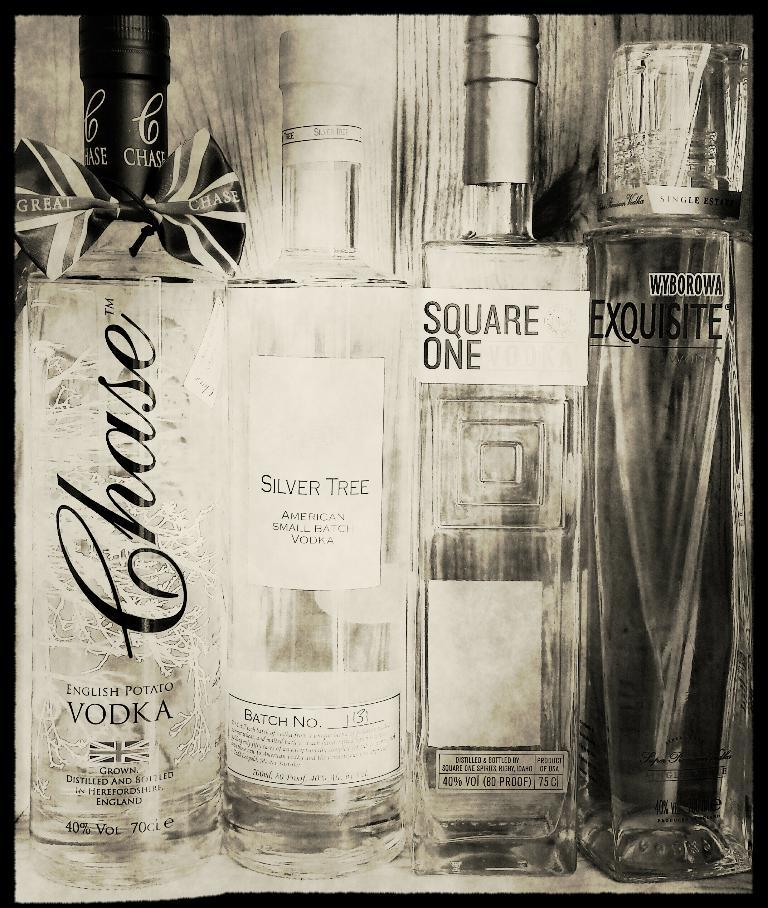How many bottles are visible in the image? There are four bottles in the image. What are the names of the different bottles? The bottles are labeled as English potato vodka, silver tree, square one, and Equiste. Which bottle has a particularly attractive design? The English potato vodka bottle is beautifully designed. What is the weight of the son in the image? There is no son present in the image, so it is not possible to determine the weight of a son. 